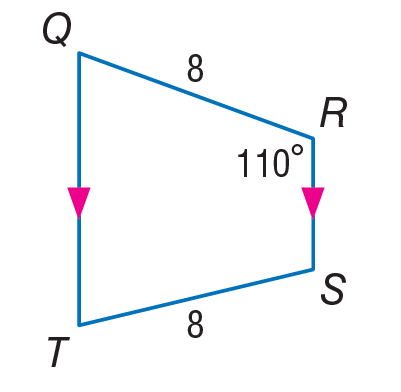Answer the mathemtical geometry problem and directly provide the correct option letter.
Question: Find m \angle Q.
Choices: A: 70 B: 90 C: 110 D: 180 A 